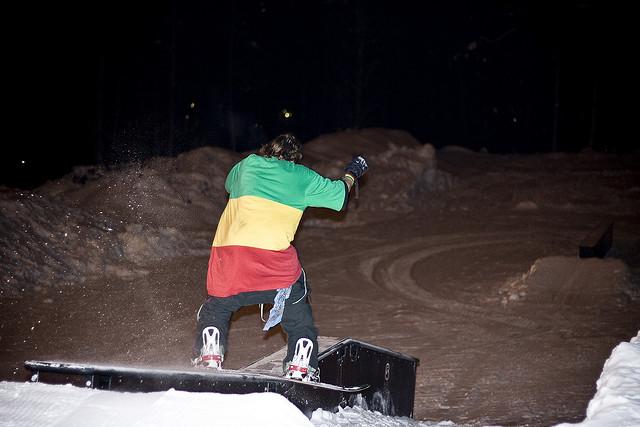What time of day is it?
Quick response, please. Night. What is he doing?
Be succinct. Snowboarding. How many colors are in the boy's shirt?
Keep it brief. 3. Where is the person skating on?
Concise answer only. Snow. 